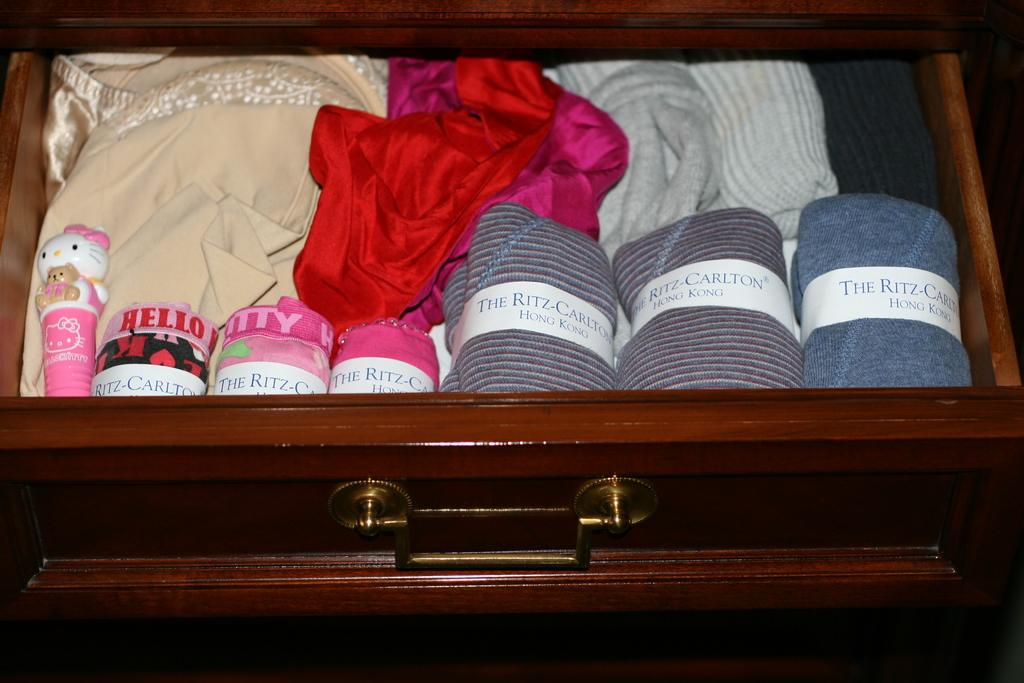<image>
Describe the image concisely. Several packs of different colored linens with the ritz carlton label on them. 